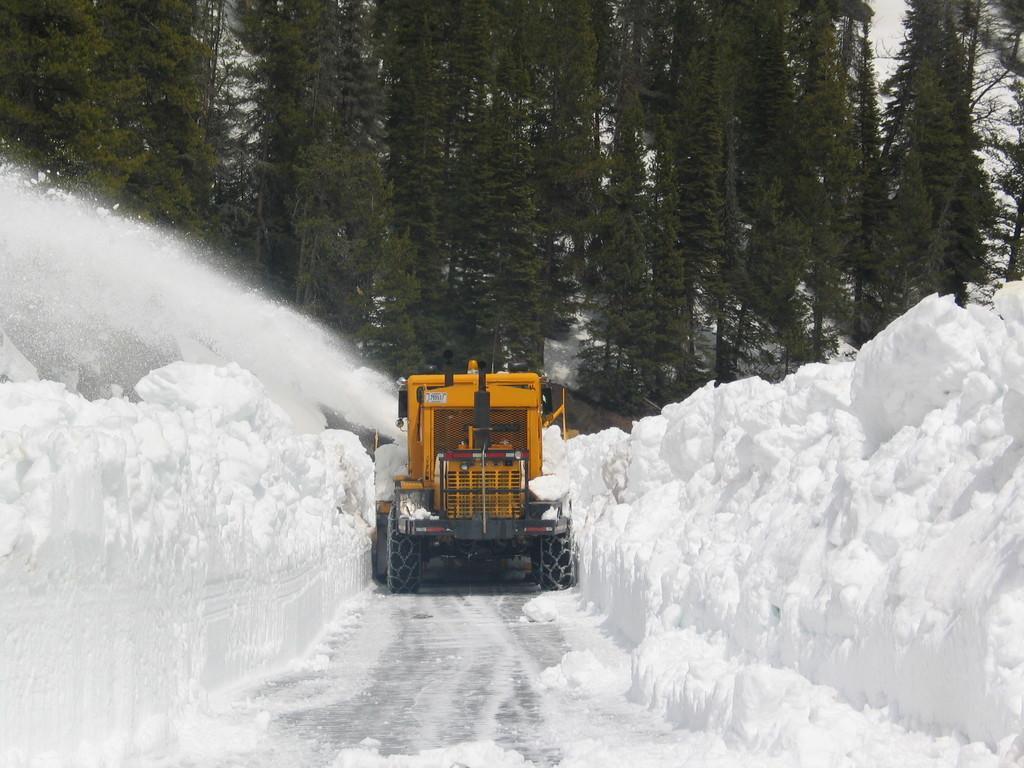In one or two sentences, can you explain what this image depicts? In this image we can see a vehicle. On the left and the right side of the image there is the snow. At the bottom of the image there is a walkway. In the background of the image there are trees and the sky. 